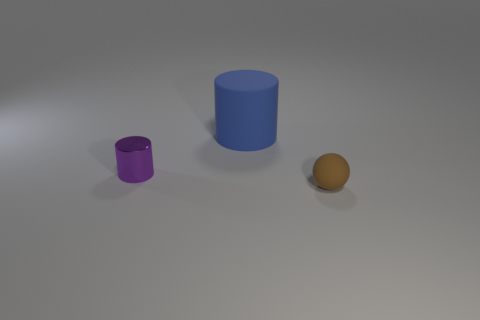Subtract all purple cylinders. How many cylinders are left? 1 Subtract all brown blocks. How many blue cylinders are left? 1 Add 2 small things. How many objects exist? 5 Subtract 1 spheres. How many spheres are left? 0 Subtract all blue cylinders. Subtract all brown spheres. How many cylinders are left? 1 Subtract all large blue rubber things. Subtract all tiny purple shiny things. How many objects are left? 1 Add 3 big blue cylinders. How many big blue cylinders are left? 4 Add 2 big blue rubber cylinders. How many big blue rubber cylinders exist? 3 Subtract 0 green balls. How many objects are left? 3 Subtract all spheres. How many objects are left? 2 